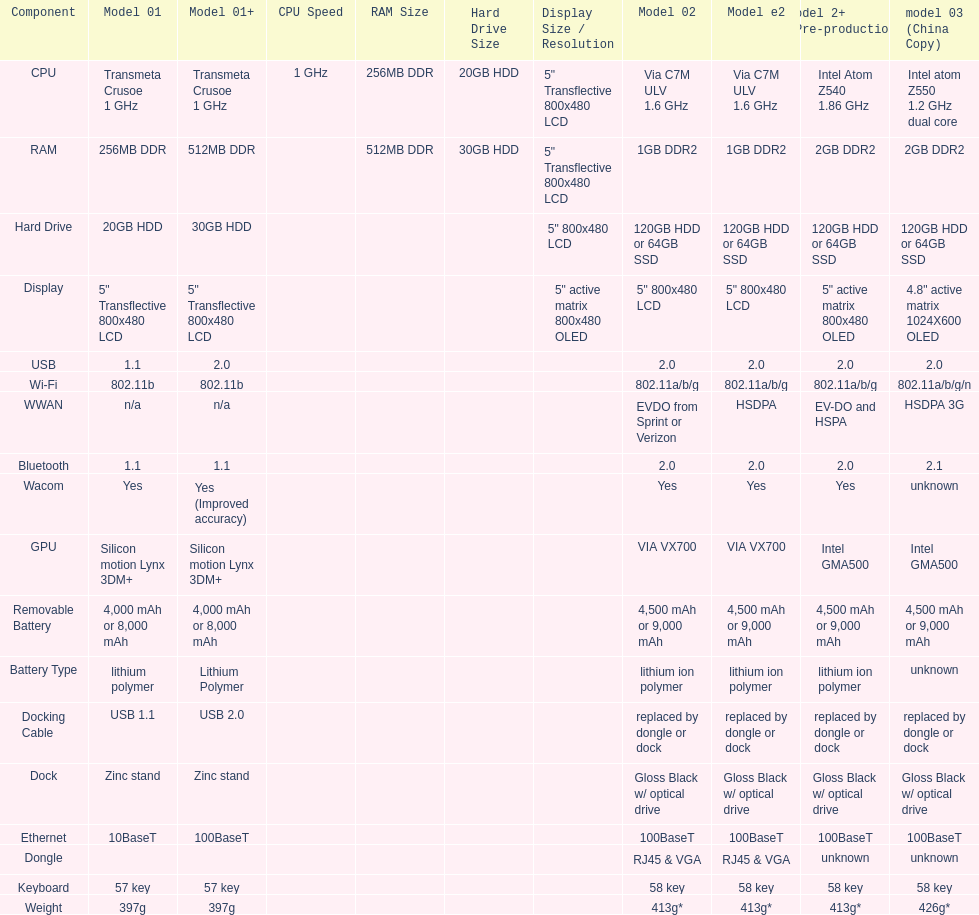The model 2 and the model 2e have what type of cpu? Via C7M ULV 1.6 GHz. 